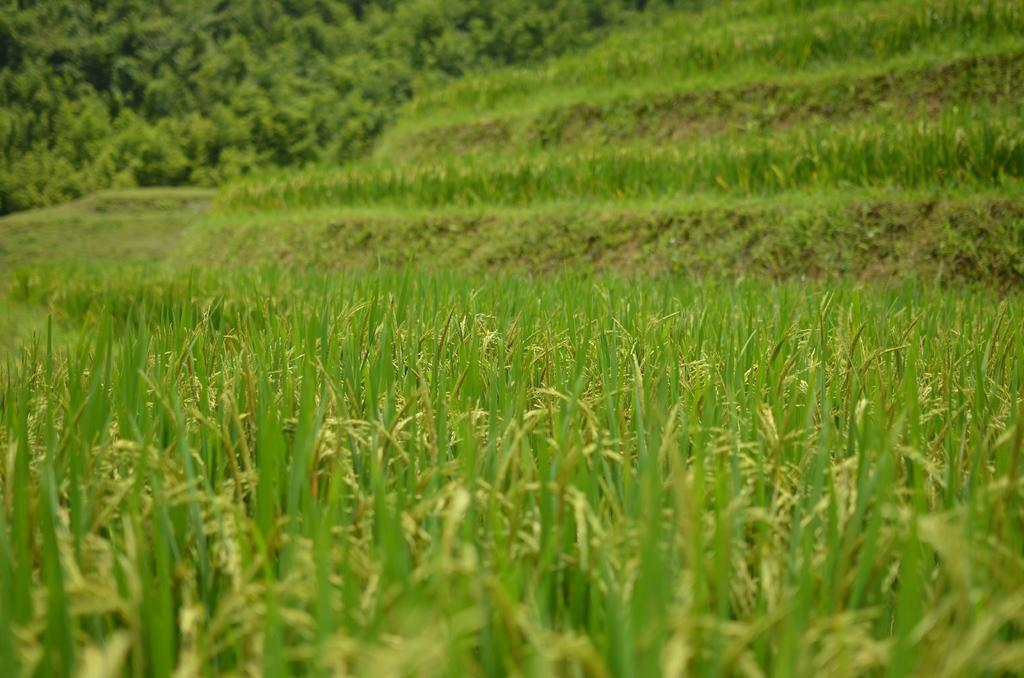What type of vegetation is present in the image? There are green plants and trees in the image. Can you describe the specific plants or trees in the image? The provided facts do not specify the types of plants or trees, only that they are green and appear to be trees. What can be inferred about the environment or setting from the presence of these plants and trees? The presence of green plants and trees suggests a natural or outdoor setting. What type of balls are being used during recess in the image? There is no reference to a recess or any balls in the image; it features green plants and trees. 